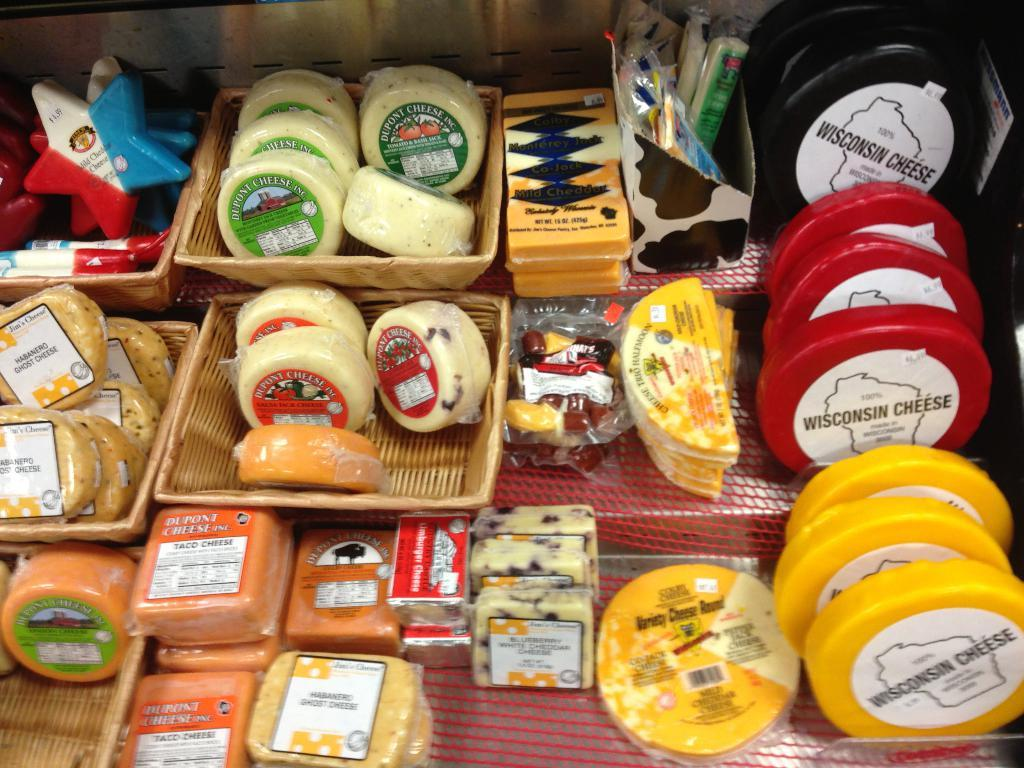<image>
Offer a succinct explanation of the picture presented. cheese selections including several types of Wisconsin cheese 